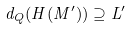Convert formula to latex. <formula><loc_0><loc_0><loc_500><loc_500>d _ { Q } ( H ( M ^ { \prime } ) ) \supseteq L ^ { \prime }</formula> 